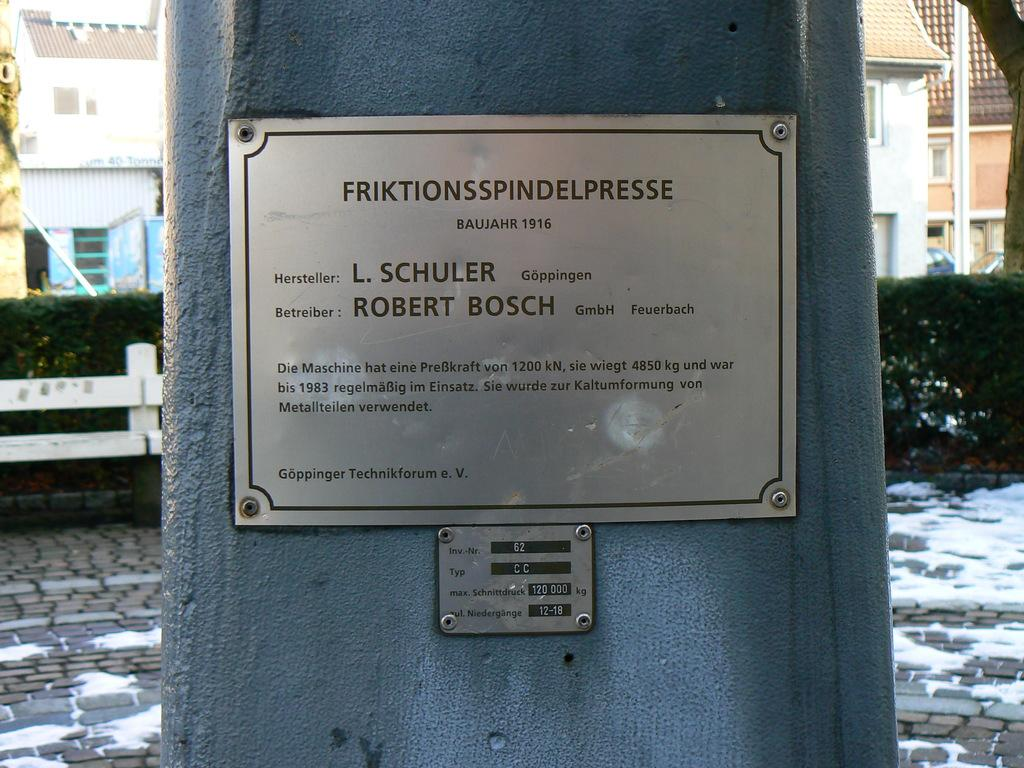What is the main object in the foreground of the image? There is a pillar with a name plate in the image. What can be seen in the background of the image? In the background, there is fencing, bushes, buildings with windows, and snow on the ground. What material is visible on the ground in the image? There are bricks on the ground in the image. What is the shape of the interest in the image? There is no interest present in the image, and therefore no shape can be determined. 